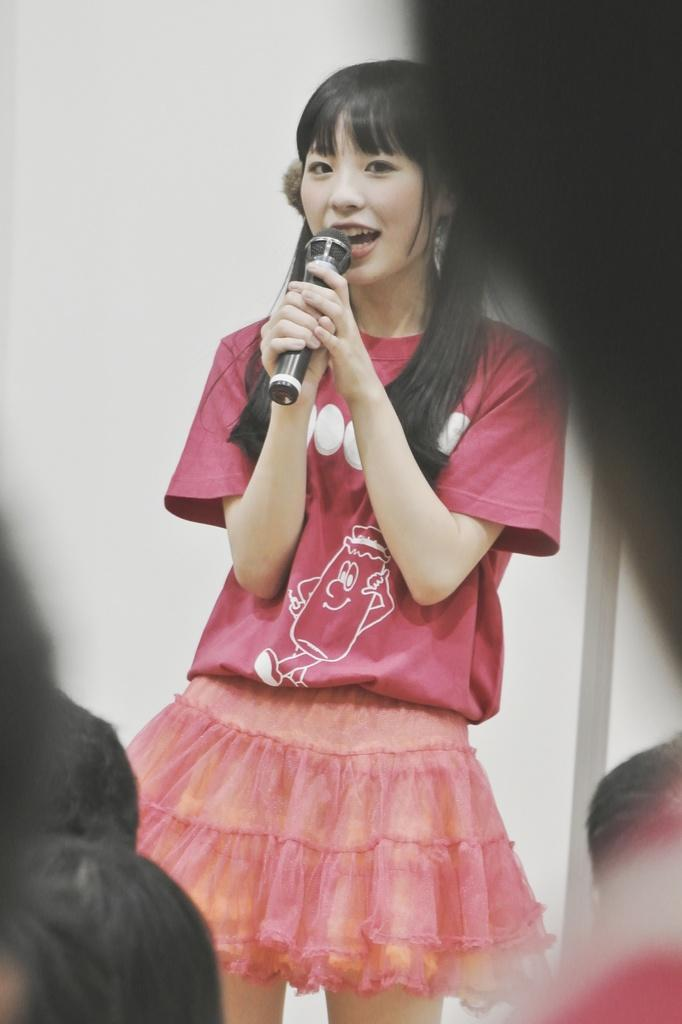Who is the main subject in the image? There is a woman in the image. Can you describe the woman's appearance? The woman is pretty. What is the woman wearing in the image? The woman is wearing a pink t-shirt and a small skirt. Where is the woman located in the image? The woman is standing on a stage. What is the woman doing in the image? The woman is singing into a microphone. How does the woman produce steam while singing in the image? The woman does not produce steam while singing in the image; there is no mention of steam or any related activity in the provided facts. 